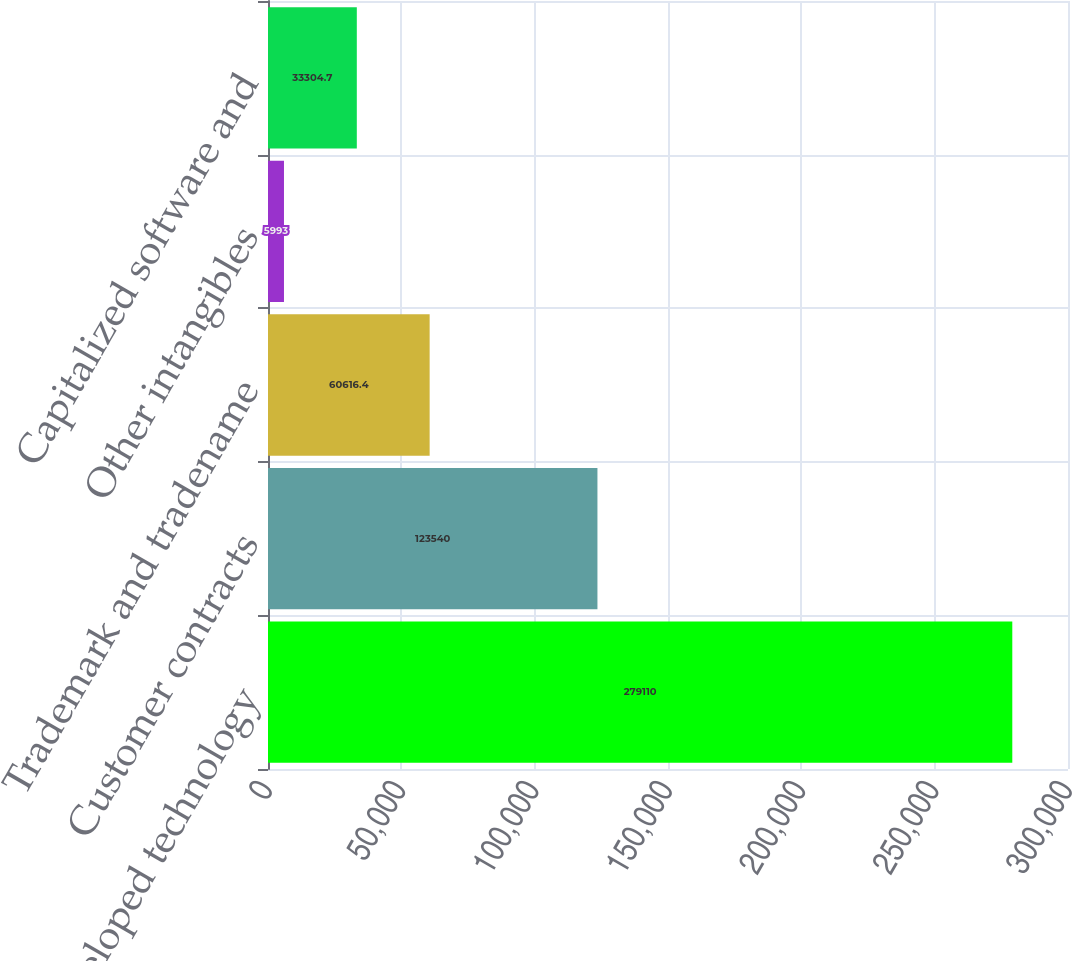Convert chart. <chart><loc_0><loc_0><loc_500><loc_500><bar_chart><fcel>Core/developed technology<fcel>Customer contracts<fcel>Trademark and tradename<fcel>Other intangibles<fcel>Capitalized software and<nl><fcel>279110<fcel>123540<fcel>60616.4<fcel>5993<fcel>33304.7<nl></chart> 